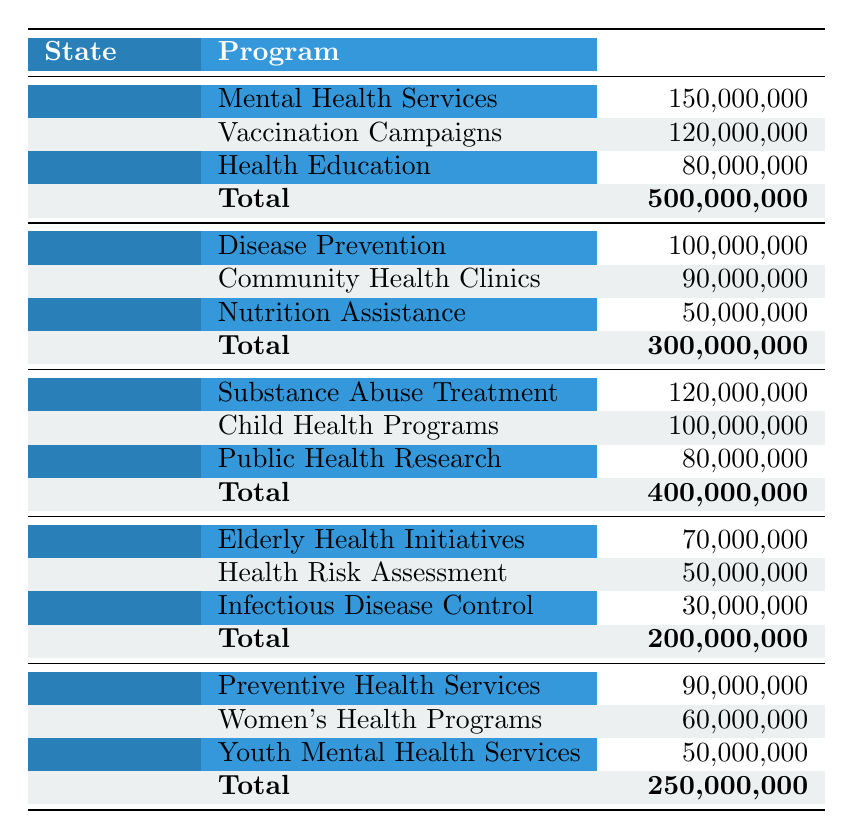What is the total budget allocation for public health initiatives in California? The total budget for California is listed directly in the table under "Total" for California, which is 500,000,000.
Answer: 500,000,000 What program received the highest allocation in Texas? By checking the allocations under the Texas row, the program "Disease Prevention" has the highest allocation of 100,000,000.
Answer: Disease Prevention Which state has the lowest total budget allocation for public health initiatives? The table shows the total budgets for each state, and Florida has the lowest total budget allocation at 200,000,000.
Answer: Florida What is the combined budget allocation for Mental Health Services in California and Women's Health Programs in Illinois? The allocation for Mental Health Services in California is 150,000,000 and for Women's Health Programs in Illinois it is 60,000,000. Adding these, 150,000,000 + 60,000,000 equals 210,000,000.
Answer: 210,000,000 Is the budget allocation for Health Education in California greater than that for Child Health Programs in New York? The allocation for Health Education in California is 80,000,000, while Child Health Programs in New York has an allocation of 100,000,000. Since 80,000,000 is less than 100,000,000, the statement is false.
Answer: No What is the average allocation of funds for public health programs in Florida? The total allocation for Florida is 200,000,000, which is the sum of three programs (70,000,000 + 50,000,000 + 30,000,000). To find the average, divide the total by the number of programs (3), resulting in an average of 200,000,000 / 3 = 66,666,667.
Answer: 66,666,667 If the budget for Vaccination Campaigns in California was reduced by 20%, what would be the new allocation? The original allocation for Vaccination Campaigns is 120,000,000. A reduction of 20% equates to 120,000,000 * 0.20, which equals 24,000,000. Therefore, the new allocation would be 120,000,000 - 24,000,000 = 96,000,000.
Answer: 96,000,000 Does Illinois allocate more funds to Preventive Health Services compared to Florida's total budget allocation? The allocation for Preventive Health Services in Illinois is 90,000,000 while Florida's total budget is 200,000,000. Since 90,000,000 is less than 200,000,000, the statement is false.
Answer: No 